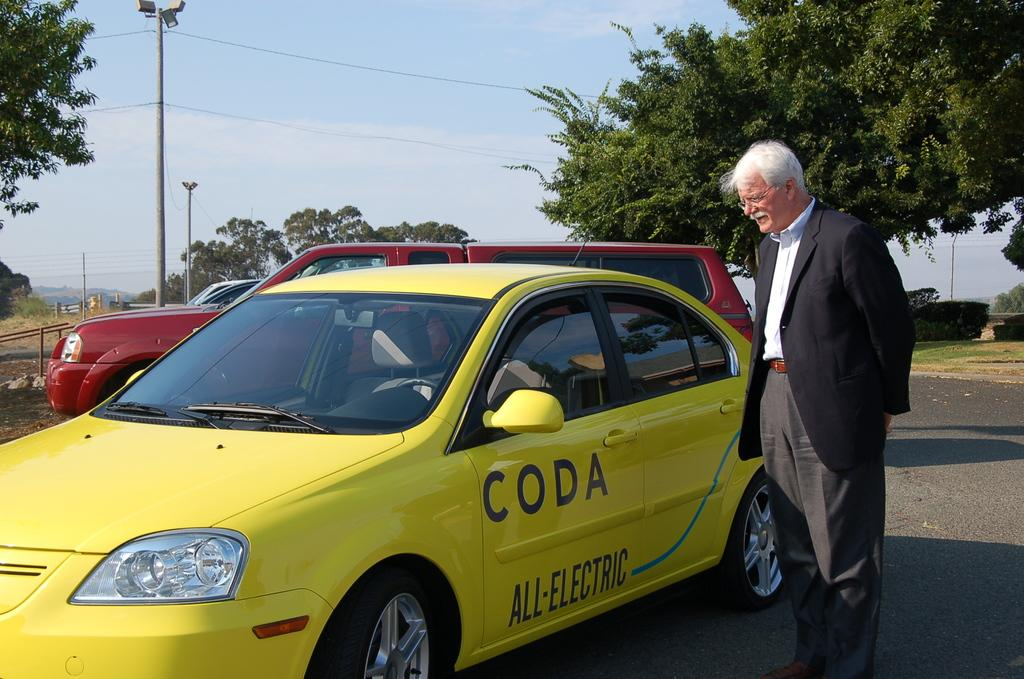<image>
Give a short and clear explanation of the subsequent image. a yellow coda all-electric car stopped as the driver speaks with a man 